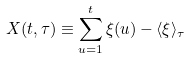<formula> <loc_0><loc_0><loc_500><loc_500>X ( t , \tau ) \equiv \sum ^ { t } _ { u = 1 } \xi ( u ) - \langle \xi \rangle _ { \tau }</formula> 